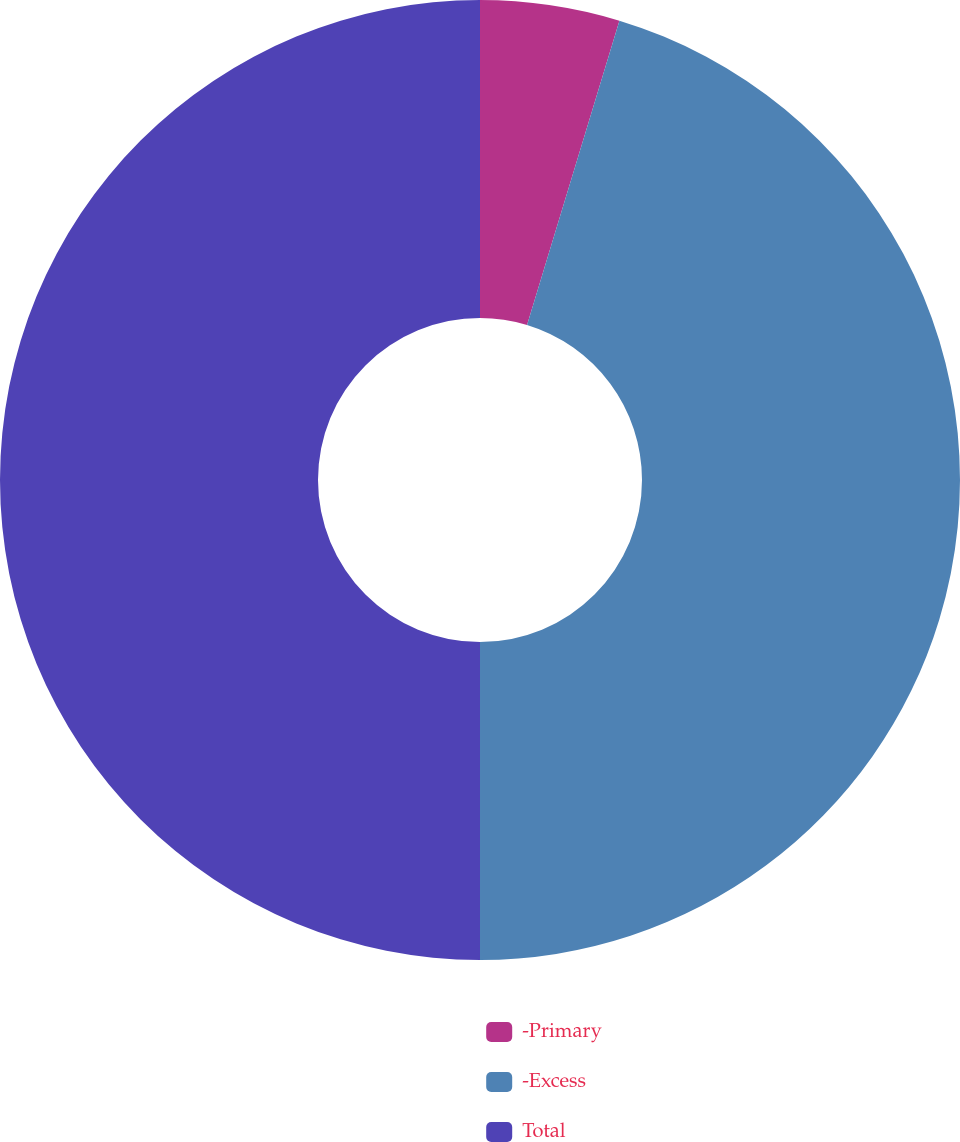Convert chart. <chart><loc_0><loc_0><loc_500><loc_500><pie_chart><fcel>-Primary<fcel>-Excess<fcel>Total<nl><fcel>4.69%<fcel>45.31%<fcel>50.0%<nl></chart> 